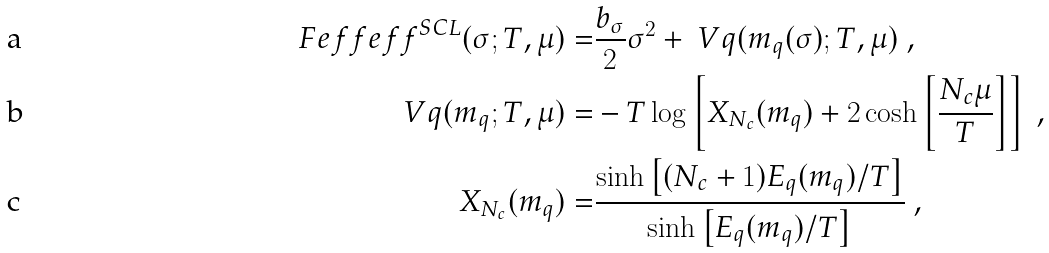<formula> <loc_0><loc_0><loc_500><loc_500>\ F e f f { e f f } ^ { S C L } ( \sigma ; T , \mu ) = & \frac { b _ { \sigma } } { 2 } \sigma ^ { 2 } + \ V q ( m _ { q } ( \sigma ) ; T , \mu ) \ , \\ \ V q ( m _ { q } ; T , \mu ) = & - T \log \left [ X _ { N _ { c } } ( m _ { q } ) + 2 \cosh \left [ \frac { N _ { c } \mu } { T } \right ] \right ] \ , \\ X _ { N _ { c } } ( m _ { q } ) = & \frac { \sinh \left [ ( N _ { c } + 1 ) E _ { q } ( m _ { q } ) / T \right ] } { \sinh \left [ E _ { q } ( m _ { q } ) / T \right ] } \ ,</formula> 